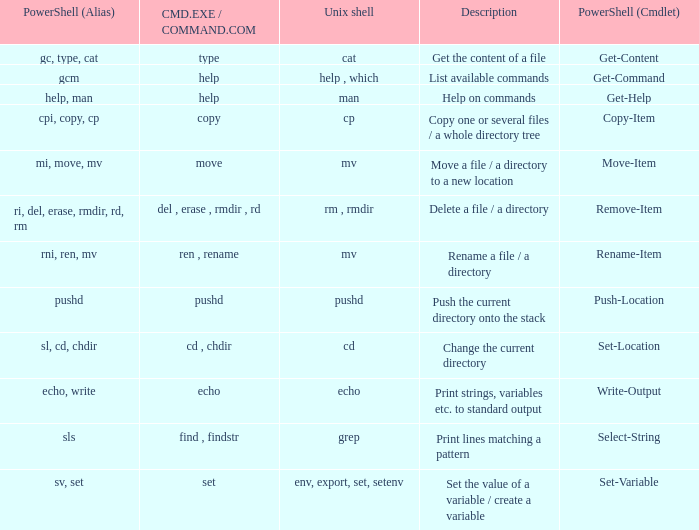When the cmd.exe / command.com is type, what are all associated values for powershell (cmdlet)? Get-Content. Write the full table. {'header': ['PowerShell (Alias)', 'CMD.EXE / COMMAND.COM', 'Unix shell', 'Description', 'PowerShell (Cmdlet)'], 'rows': [['gc, type, cat', 'type', 'cat', 'Get the content of a file', 'Get-Content'], ['gcm', 'help', 'help , which', 'List available commands', 'Get-Command'], ['help, man', 'help', 'man', 'Help on commands', 'Get-Help'], ['cpi, copy, cp', 'copy', 'cp', 'Copy one or several files / a whole directory tree', 'Copy-Item'], ['mi, move, mv', 'move', 'mv', 'Move a file / a directory to a new location', 'Move-Item'], ['ri, del, erase, rmdir, rd, rm', 'del , erase , rmdir , rd', 'rm , rmdir', 'Delete a file / a directory', 'Remove-Item'], ['rni, ren, mv', 'ren , rename', 'mv', 'Rename a file / a directory', 'Rename-Item'], ['pushd', 'pushd', 'pushd', 'Push the current directory onto the stack', 'Push-Location'], ['sl, cd, chdir', 'cd , chdir', 'cd', 'Change the current directory', 'Set-Location'], ['echo, write', 'echo', 'echo', 'Print strings, variables etc. to standard output', 'Write-Output'], ['sls', 'find , findstr', 'grep', 'Print lines matching a pattern', 'Select-String'], ['sv, set', 'set', 'env, export, set, setenv', 'Set the value of a variable / create a variable', 'Set-Variable']]} 